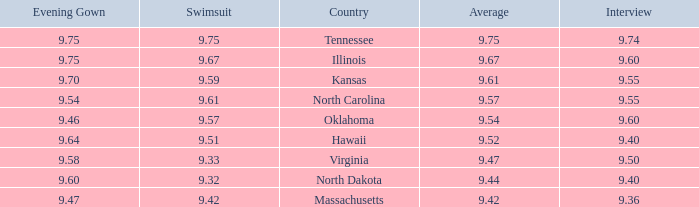Would you mind parsing the complete table? {'header': ['Evening Gown', 'Swimsuit', 'Country', 'Average', 'Interview'], 'rows': [['9.75', '9.75', 'Tennessee', '9.75', '9.74'], ['9.75', '9.67', 'Illinois', '9.67', '9.60'], ['9.70', '9.59', 'Kansas', '9.61', '9.55'], ['9.54', '9.61', 'North Carolina', '9.57', '9.55'], ['9.46', '9.57', 'Oklahoma', '9.54', '9.60'], ['9.64', '9.51', 'Hawaii', '9.52', '9.40'], ['9.58', '9.33', 'Virginia', '9.47', '9.50'], ['9.60', '9.32', 'North Dakota', '9.44', '9.40'], ['9.47', '9.42', 'Massachusetts', '9.42', '9.36']]} What was the average for the country with the swimsuit score of 9.57? 9.54. 